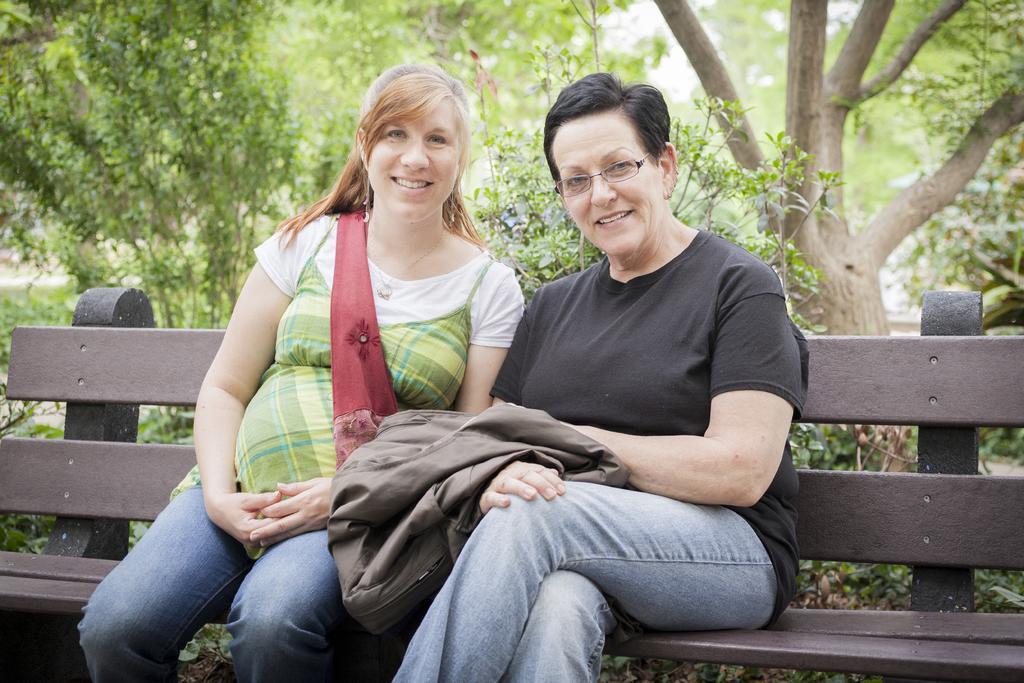Please provide a concise description of this image. In this image I can see two persons sitting on the bench and the person at right is wearing black shirt, blue pant and the person at left is wearing green shirt, blue pant. Background I can see trees in green color and the sky is in white color. 